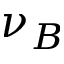Convert formula to latex. <formula><loc_0><loc_0><loc_500><loc_500>\nu _ { B }</formula> 